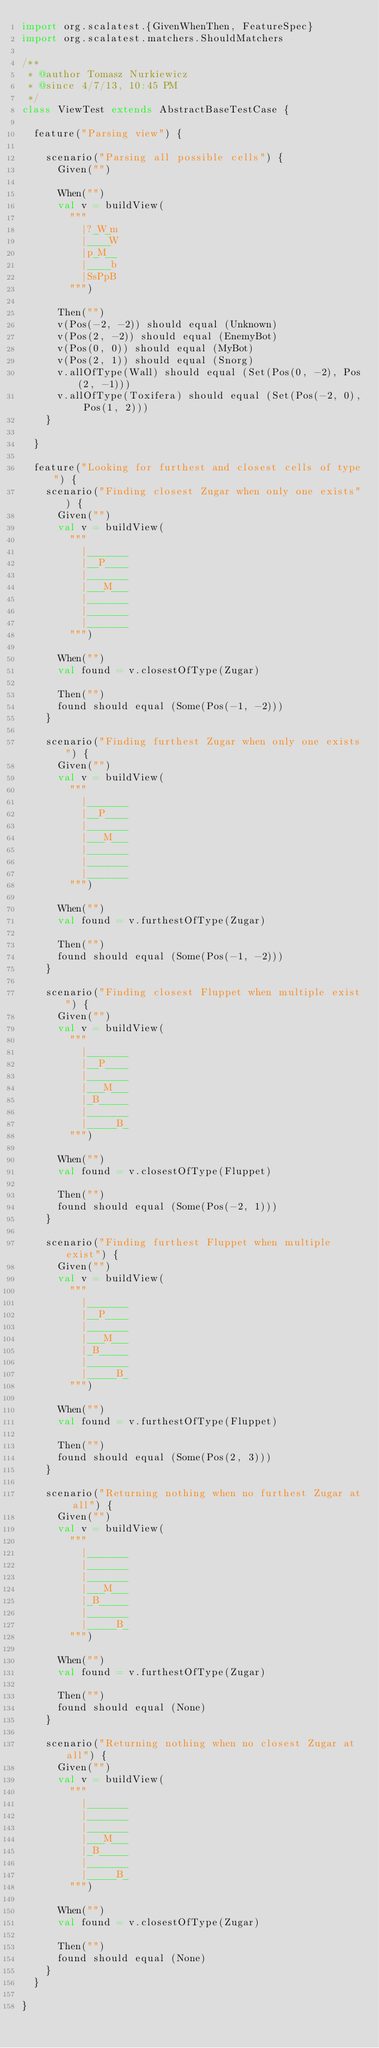<code> <loc_0><loc_0><loc_500><loc_500><_Scala_>import org.scalatest.{GivenWhenThen, FeatureSpec}
import org.scalatest.matchers.ShouldMatchers

/**
 * @author Tomasz Nurkiewicz
 * @since 4/7/13, 10:45 PM
 */
class ViewTest extends AbstractBaseTestCase {

	feature("Parsing view") {

		scenario("Parsing all possible cells") {
			Given("")

			When("")
			val v = buildView(
				"""
				  |?_W_m
				  |____W
				  |p_M__
				  |____b
				  |SsPpB
				""")

			Then("")
			v(Pos(-2, -2)) should equal (Unknown)
			v(Pos(2, -2)) should equal (EnemyBot)
			v(Pos(0, 0)) should equal (MyBot)
			v(Pos(2, 1)) should equal (Snorg)
			v.allOfType(Wall) should equal (Set(Pos(0, -2), Pos(2, -1)))
			v.allOfType(Toxifera) should equal (Set(Pos(-2, 0), Pos(1, 2)))
		}

	}

	feature("Looking for furthest and closest cells of type") {
		scenario("Finding closest Zugar when only one exists") {
			Given("")
			val v = buildView(
				"""
				  |_______
				  |__P____
				  |_______
				  |___M___
				  |_______
				  |_______
				  |_______
				""")

			When("")
			val found = v.closestOfType(Zugar)

			Then("")
			found should equal (Some(Pos(-1, -2)))
		}

		scenario("Finding furthest Zugar when only one exists") {
			Given("")
			val v = buildView(
				"""
				  |_______
				  |__P____
				  |_______
				  |___M___
				  |_______
				  |_______
				  |_______
				""")

			When("")
			val found = v.furthestOfType(Zugar)

			Then("")
			found should equal (Some(Pos(-1, -2)))
		}

		scenario("Finding closest Fluppet when multiple exist") {
			Given("")
			val v = buildView(
				"""
				  |_______
				  |__P____
				  |_______
				  |___M___
				  |_B_____
				  |_______
				  |_____B_
				""")

			When("")
			val found = v.closestOfType(Fluppet)

			Then("")
			found should equal (Some(Pos(-2, 1)))
		}

		scenario("Finding furthest Fluppet when multiple exist") {
			Given("")
			val v = buildView(
				"""
				  |_______
				  |__P____
				  |_______
				  |___M___
				  |_B_____
				  |_______
				  |_____B_
				""")

			When("")
			val found = v.furthestOfType(Fluppet)

			Then("")
			found should equal (Some(Pos(2, 3)))
		}

		scenario("Returning nothing when no furthest Zugar at all") {
			Given("")
			val v = buildView(
				"""
				  |_______
				  |_______
				  |_______
				  |___M___
				  |_B_____
				  |_______
				  |_____B_
				""")

			When("")
			val found = v.furthestOfType(Zugar)

			Then("")
			found should equal (None)
		}

		scenario("Returning nothing when no closest Zugar at all") {
			Given("")
			val v = buildView(
				"""
				  |_______
				  |_______
				  |_______
				  |___M___
				  |_B_____
				  |_______
				  |_____B_
				""")

			When("")
			val found = v.closestOfType(Zugar)

			Then("")
			found should equal (None)
		}
	}

}
</code> 